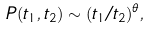Convert formula to latex. <formula><loc_0><loc_0><loc_500><loc_500>P ( t _ { 1 } , t _ { 2 } ) \sim ( t _ { 1 } / t _ { 2 } ) ^ { \theta } ,</formula> 